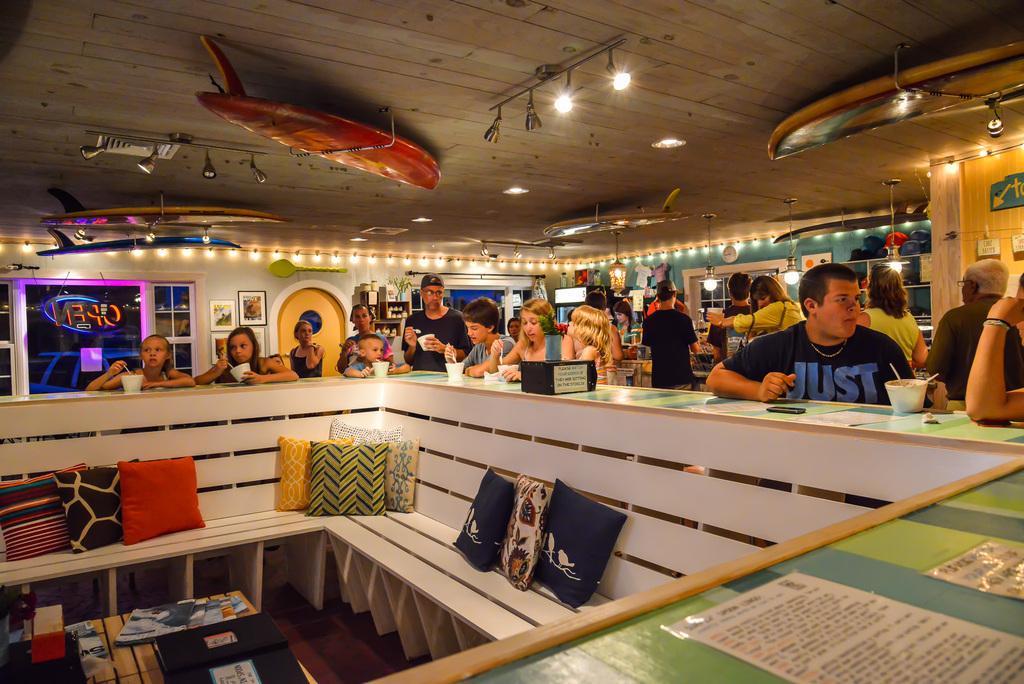Describe this image in one or two sentences. In this image there are few people in the room in which some of them are around the table and eating some food item, on the table there are plastic bowls and posters, there are few pillows on the benches, few books on the wooden table, a few lights and objects hanging from the roof, there are a few posts attached to the rope. 